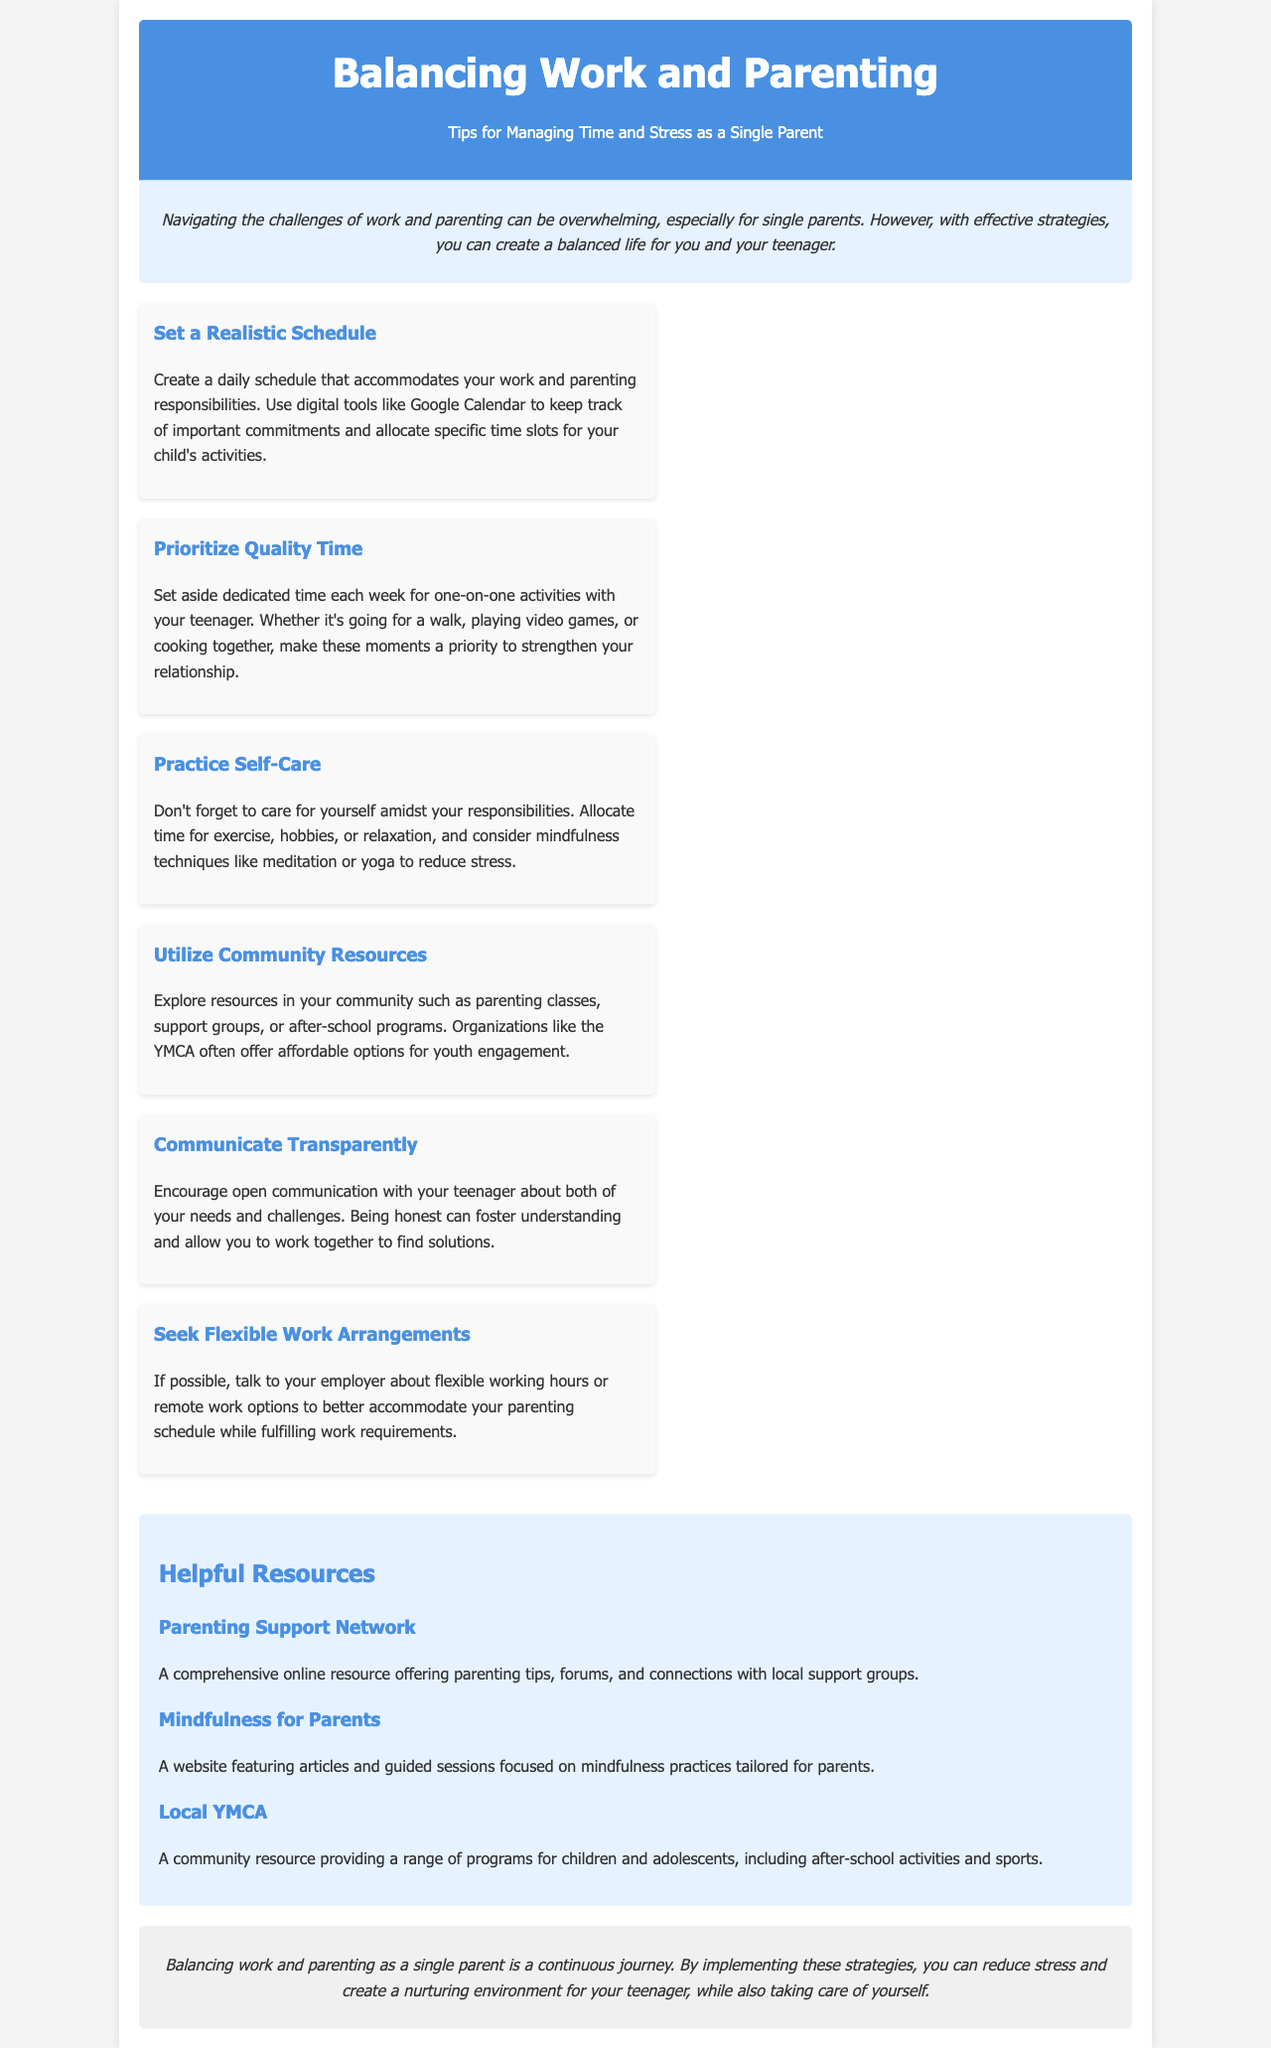what is the title of the brochure? The title of the brochure is prominently displayed in the header section.
Answer: Balancing Work and Parenting: Tips for Managing Time and Stress as a Single Parent how many tips are provided in the document? The document lists various tips for single parents in the tips section.
Answer: Six which resource focuses on mindfulness practices? The document includes helpful resources with descriptions about each.
Answer: Mindfulness for Parents what activity is suggested for one-on-one time with a teenager? The tip about prioritizing quality time suggests activities to engage with a teenager.
Answer: Cooking together what is highlighted as an essential practice for self-care? Self-care practices are emphasized in one of the tips for managing stress.
Answer: Exercise who can benefit from the community resource YMCA mentioned? The resource section indicates services available through the YMCA for specific demographics.
Answer: Children and adolescents 